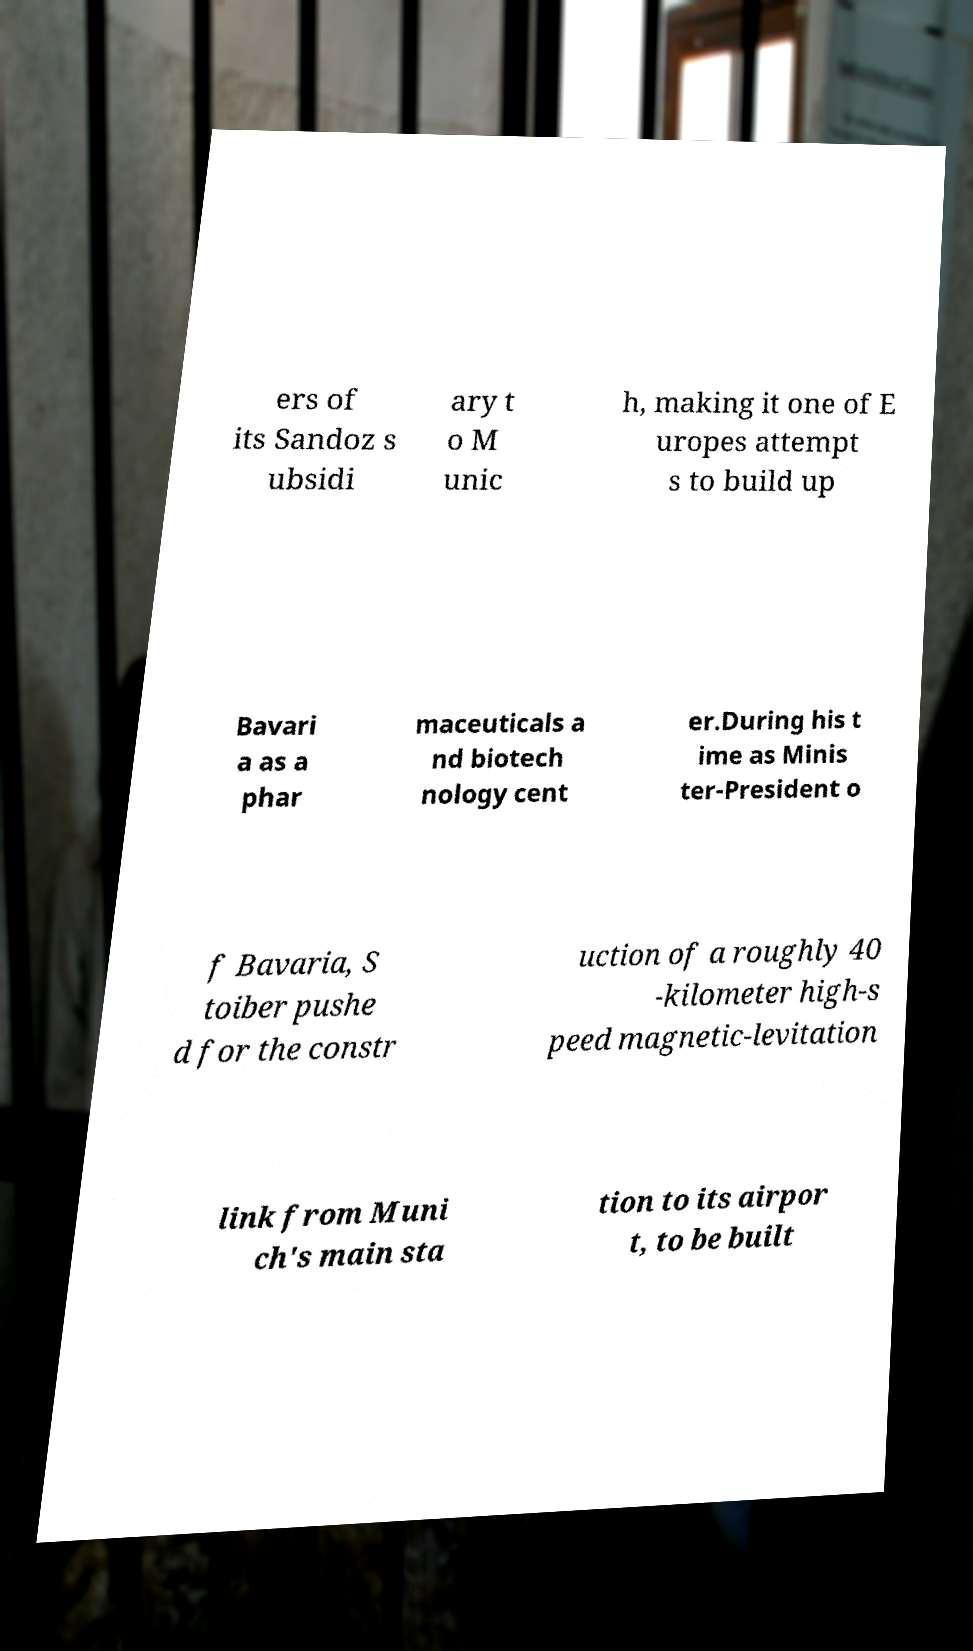Could you extract and type out the text from this image? ers of its Sandoz s ubsidi ary t o M unic h, making it one of E uropes attempt s to build up Bavari a as a phar maceuticals a nd biotech nology cent er.During his t ime as Minis ter-President o f Bavaria, S toiber pushe d for the constr uction of a roughly 40 -kilometer high-s peed magnetic-levitation link from Muni ch's main sta tion to its airpor t, to be built 